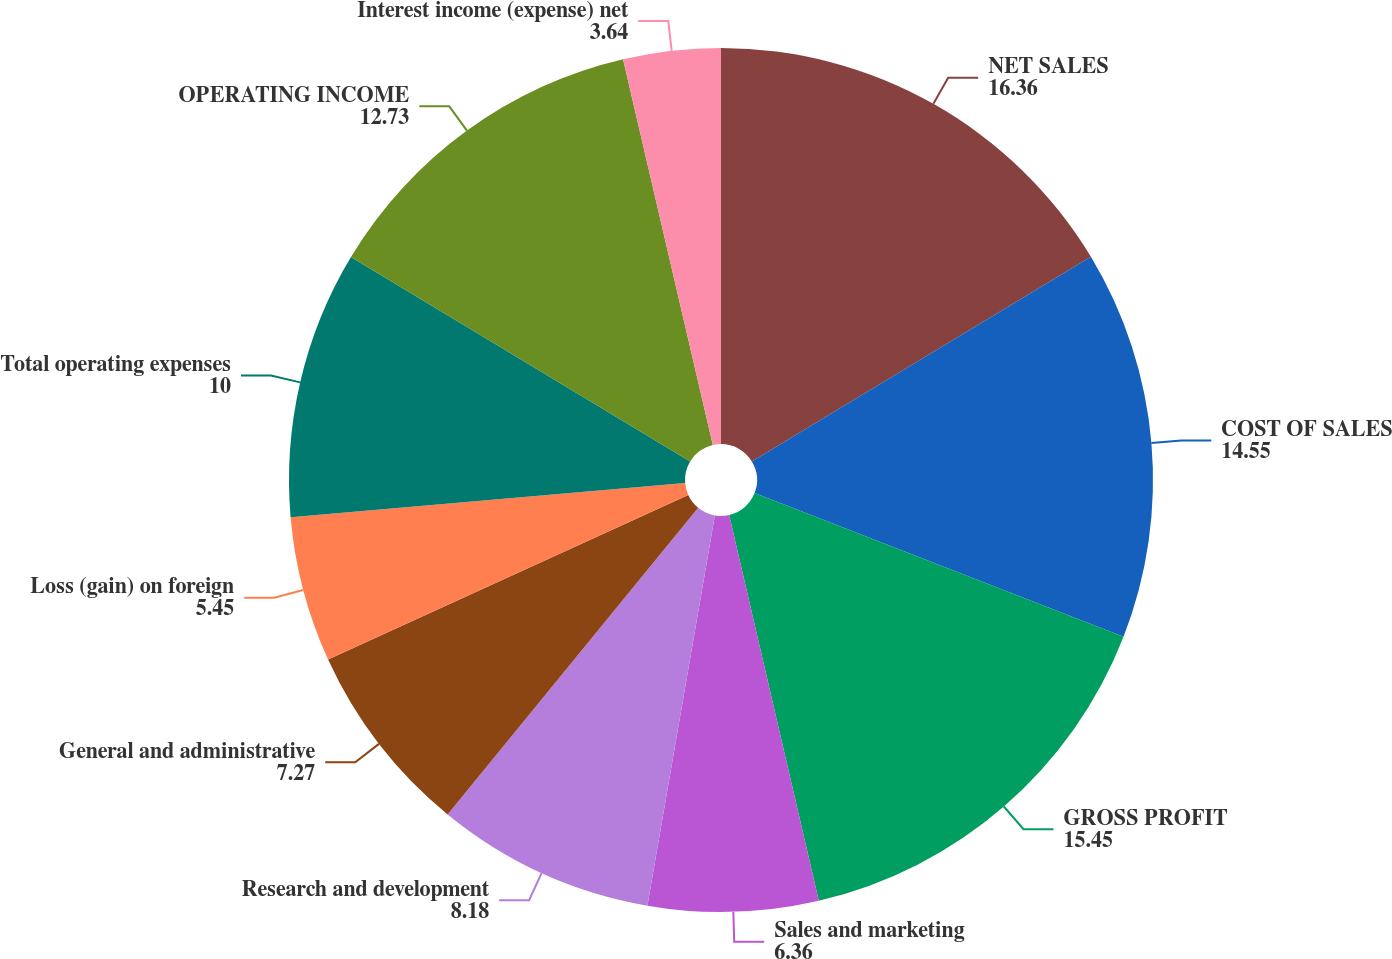Convert chart to OTSL. <chart><loc_0><loc_0><loc_500><loc_500><pie_chart><fcel>NET SALES<fcel>COST OF SALES<fcel>GROSS PROFIT<fcel>Sales and marketing<fcel>Research and development<fcel>General and administrative<fcel>Loss (gain) on foreign<fcel>Total operating expenses<fcel>OPERATING INCOME<fcel>Interest income (expense) net<nl><fcel>16.36%<fcel>14.55%<fcel>15.45%<fcel>6.36%<fcel>8.18%<fcel>7.27%<fcel>5.45%<fcel>10.0%<fcel>12.73%<fcel>3.64%<nl></chart> 